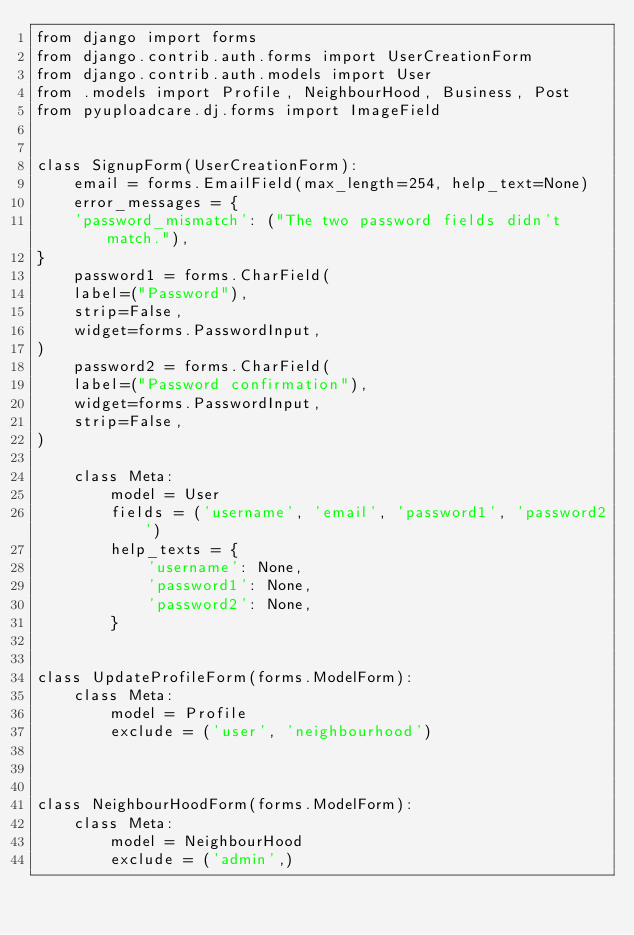<code> <loc_0><loc_0><loc_500><loc_500><_Python_>from django import forms
from django.contrib.auth.forms import UserCreationForm
from django.contrib.auth.models import User
from .models import Profile, NeighbourHood, Business, Post
from pyuploadcare.dj.forms import ImageField


class SignupForm(UserCreationForm):
    email = forms.EmailField(max_length=254, help_text=None)
    error_messages = {
    'password_mismatch': ("The two password fields didn't match."),
}
    password1 = forms.CharField(
    label=("Password"),
    strip=False,
    widget=forms.PasswordInput,
)
    password2 = forms.CharField(
    label=("Password confirmation"),
    widget=forms.PasswordInput,
    strip=False,
)

    class Meta:
        model = User
        fields = ('username', 'email', 'password1', 'password2')
        help_texts = {
            'username': None,
            'password1': None,
            'password2': None,
        }


class UpdateProfileForm(forms.ModelForm):
    class Meta:
        model = Profile
        exclude = ('user', 'neighbourhood')
    


class NeighbourHoodForm(forms.ModelForm):
    class Meta:
        model = NeighbourHood
        exclude = ('admin',)

</code> 